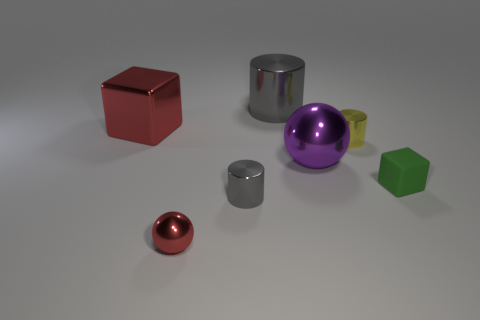Add 2 yellow cylinders. How many objects exist? 9 Subtract all blocks. How many objects are left? 5 Add 6 small green matte things. How many small green matte things exist? 7 Subtract 1 red blocks. How many objects are left? 6 Subtract all brown shiny balls. Subtract all big red blocks. How many objects are left? 6 Add 5 tiny gray cylinders. How many tiny gray cylinders are left? 6 